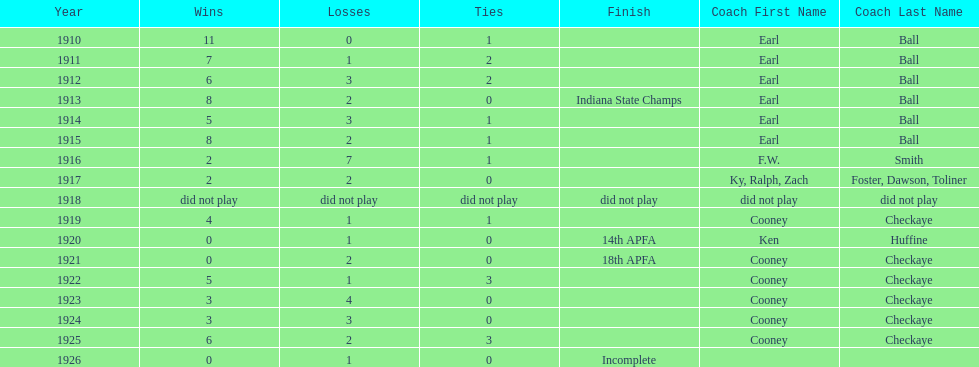In what year did the muncie flyers have an undefeated record? 1910. 